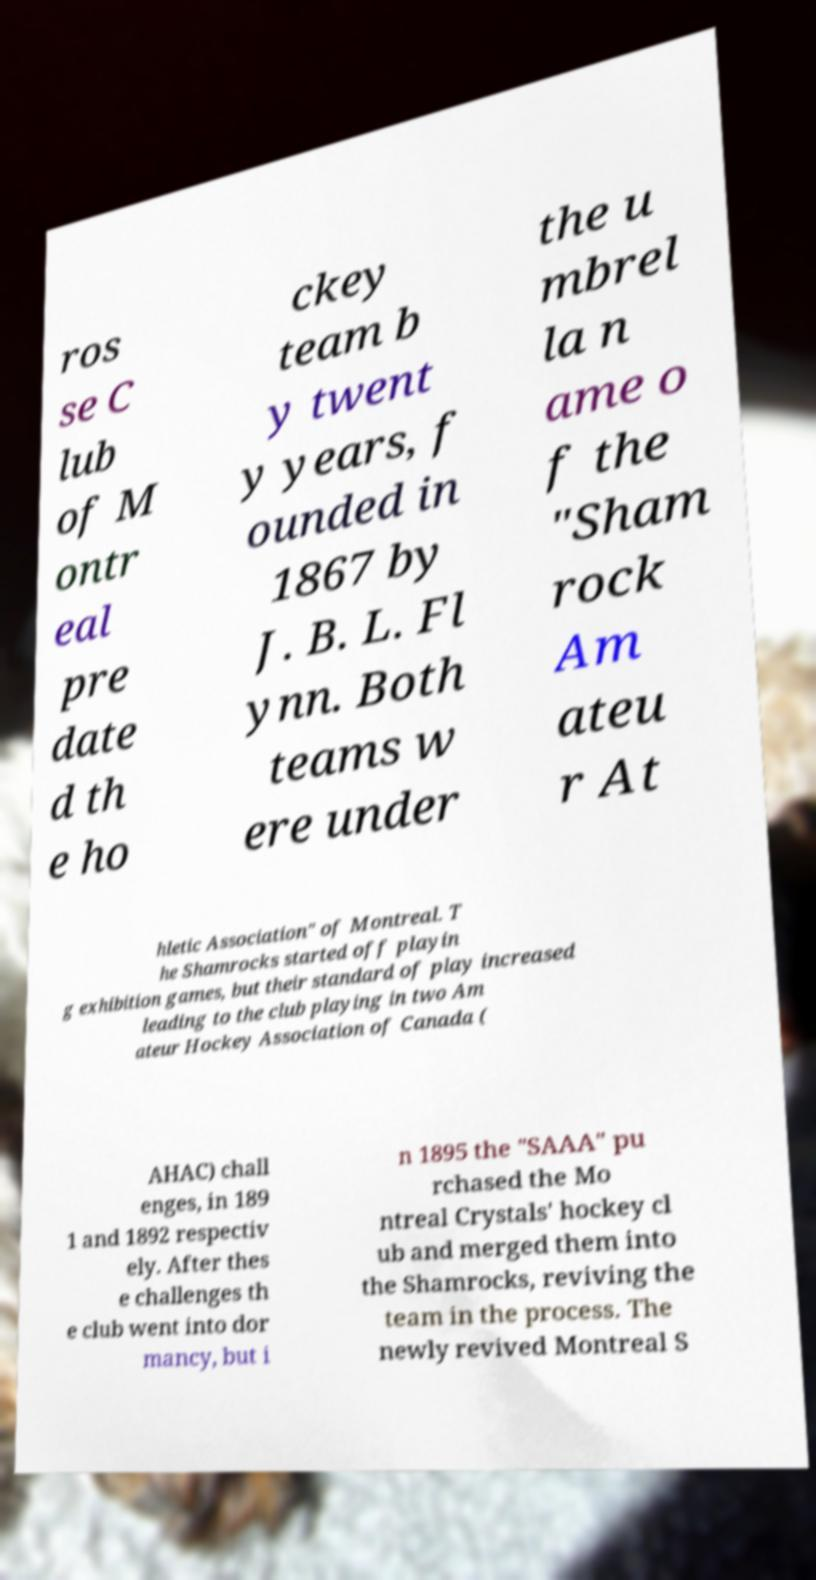Could you extract and type out the text from this image? ros se C lub of M ontr eal pre date d th e ho ckey team b y twent y years, f ounded in 1867 by J. B. L. Fl ynn. Both teams w ere under the u mbrel la n ame o f the "Sham rock Am ateu r At hletic Association" of Montreal. T he Shamrocks started off playin g exhibition games, but their standard of play increased leading to the club playing in two Am ateur Hockey Association of Canada ( AHAC) chall enges, in 189 1 and 1892 respectiv ely. After thes e challenges th e club went into dor mancy, but i n 1895 the "SAAA" pu rchased the Mo ntreal Crystals' hockey cl ub and merged them into the Shamrocks, reviving the team in the process. The newly revived Montreal S 